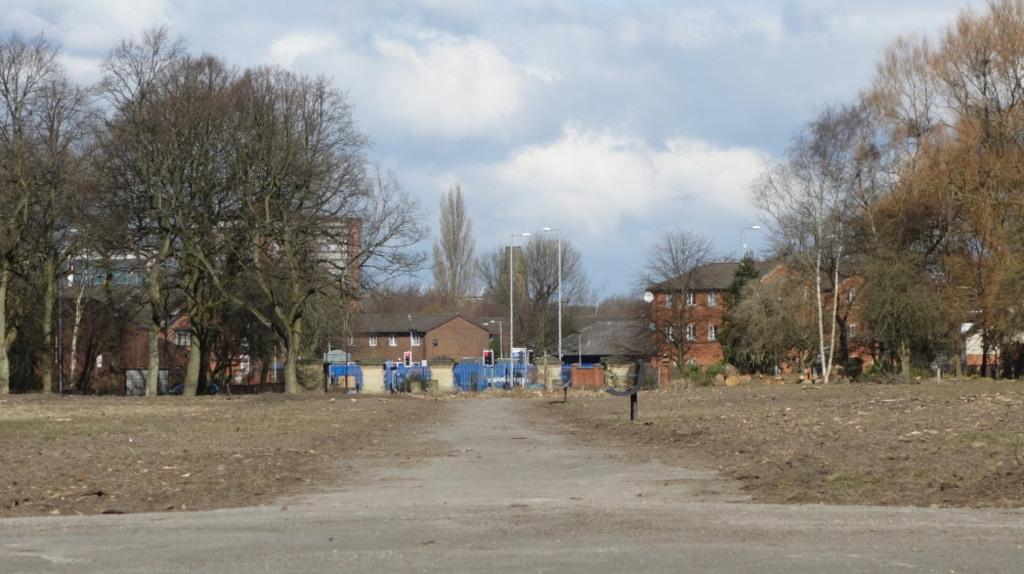What is the main feature of the image? There is a road in the image. What can be seen on the ground in the image? The ground is visible in the image. What color are the poles in the image? The poles in the image are black. What type of vegetation is present in the image? There are trees in the image. What structures can be seen in the background of the image? There are buildings and street light poles in the background of the image. What part of the natural environment is visible in the background of the image? The sky is visible in the background of the image. Can you tell me how many snails are crawling on the son's head in the image? There are no snails or people present in the image, so it is not possible to answer that question. 